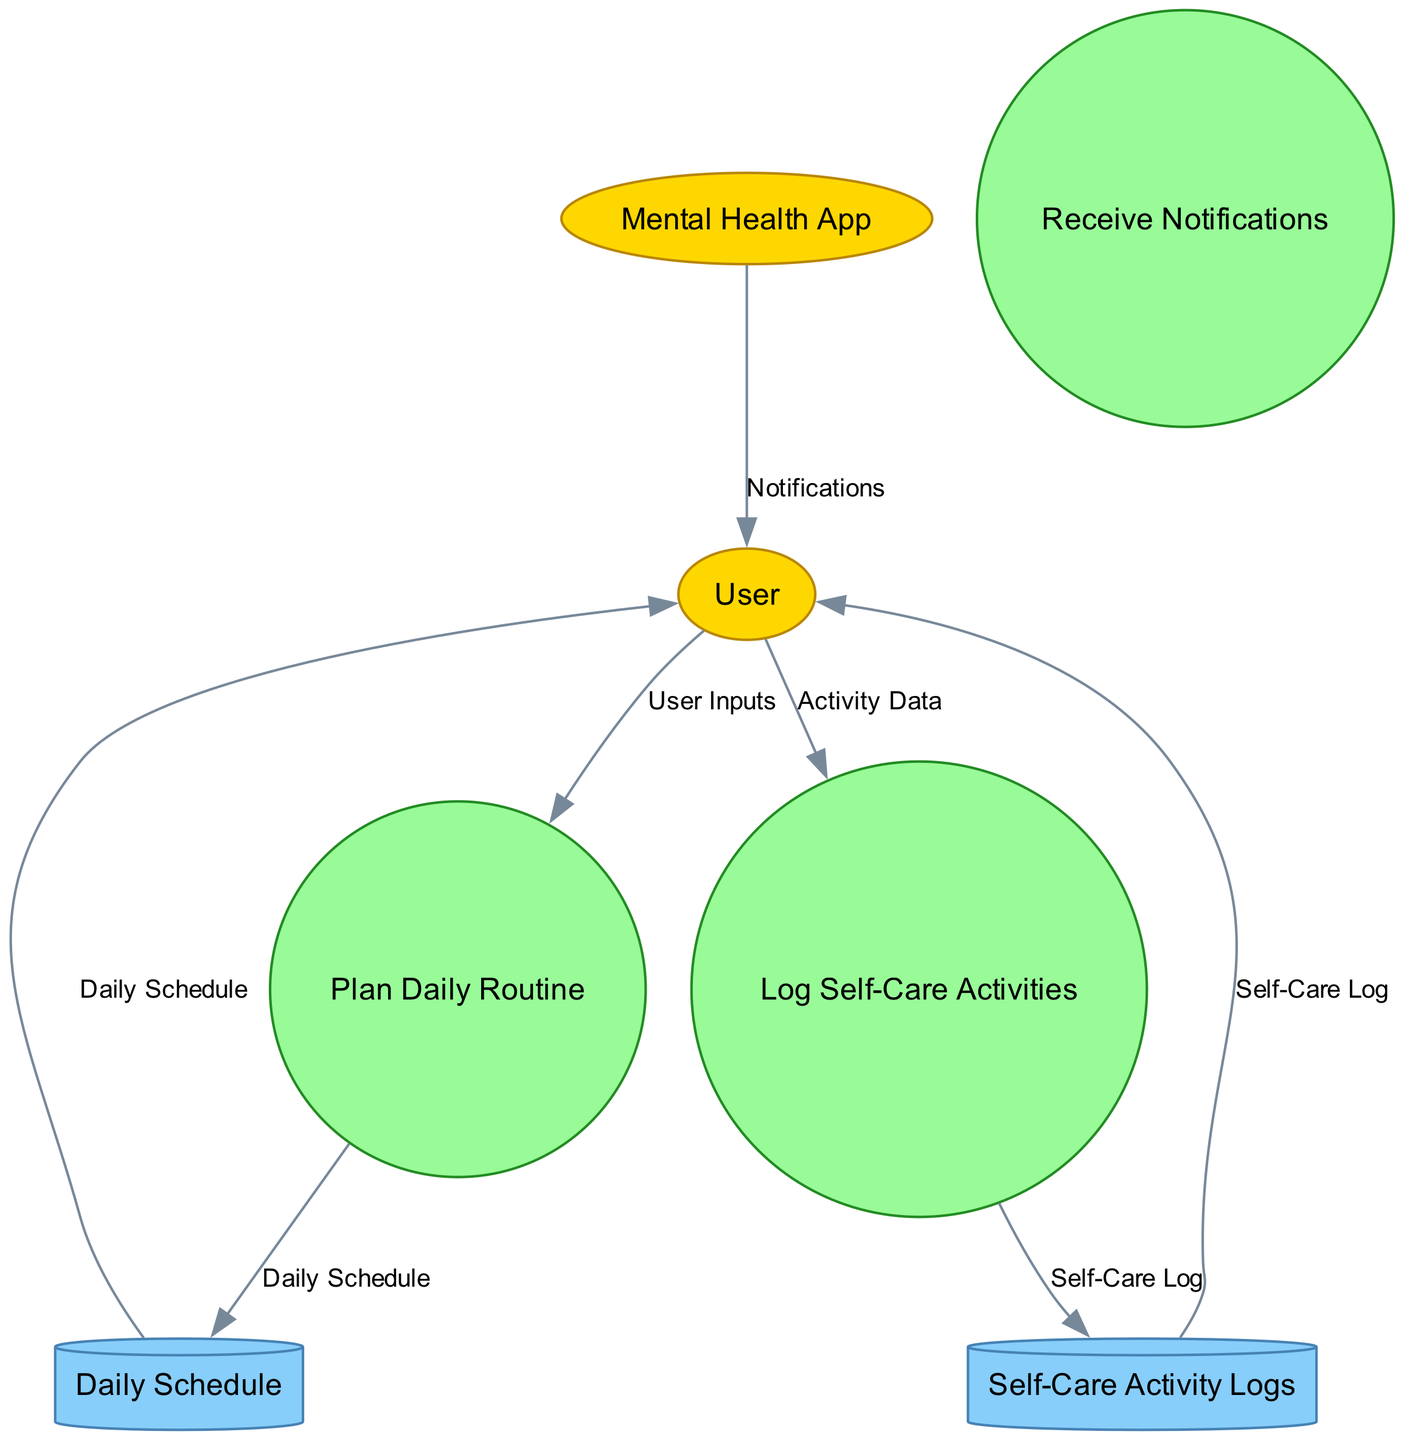What entities are involved in the diagram? The external entities listed are the User and the Mental Health App, which are depicted as ellipses in the diagram.
Answer: User, Mental Health App What is the first process in the diagram? The processes are listed in the order they are executed, with the first process being "Plan Daily Routine."
Answer: Plan Daily Routine How many data stores are present in the diagram? There are two data stores shown in the diagram, which are "Daily Schedule" and "Self-Care Activity Logs."
Answer: 2 What is the output of the "Log Self-Care Activities" process? This process outputs a "Self-Care Log," which indicates the details of activities logged by the user.
Answer: Self-Care Log What type of store is "Daily Schedule"? The "Daily Schedule" is categorized as a data store, specifically represented as a cylinder in the diagram.
Answer: Data Store What does the "Receive Notifications" process output? The "Receive Notifications" process results in "User Notifications," which are reminders sent to the user.
Answer: User Notifications Which external entity provides notifications? The "Mental Health App" is identified as the external entity that provides notifications to the user.
Answer: Mental Health App What type of node represents the "Self-Care Activity Logs"? The "Self-Care Activity Logs" are represented as a cylinder, indicating it is a data store in the context of the diagram.
Answer: Cylinder How does the User obtain their planned daily schedule? The User obtains their planned daily schedule through the flow from the "Daily Schedule" data store, which connects to the User node.
Answer: From the Daily Schedule data store Which process requires "Activity Data" as an input? The process "Log Self-Care Activities" requires "Activity Data" as one of its inputs to log the user's activities.
Answer: Log Self-Care Activities 